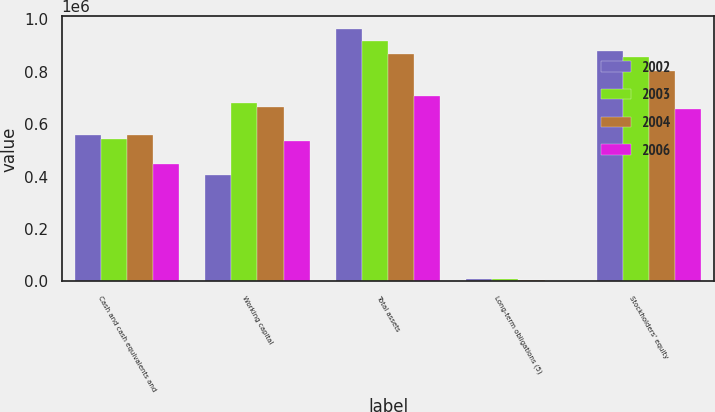<chart> <loc_0><loc_0><loc_500><loc_500><stacked_bar_chart><ecel><fcel>Cash and cash equivalents and<fcel>Working capital<fcel>Total assets<fcel>Long-term obligations (5)<fcel>Stockholders' equity<nl><fcel>2002<fcel>559189<fcel>404836<fcel>963142<fcel>9969<fcel>877681<nl><fcel>2003<fcel>544239<fcel>680554<fcel>918415<fcel>7709<fcel>857972<nl><fcel>2004<fcel>557993<fcel>665062<fcel>868044<fcel>4011<fcel>803893<nl><fcel>2006<fcel>447848<fcel>535816<fcel>706530<fcel>2853<fcel>657557<nl></chart> 